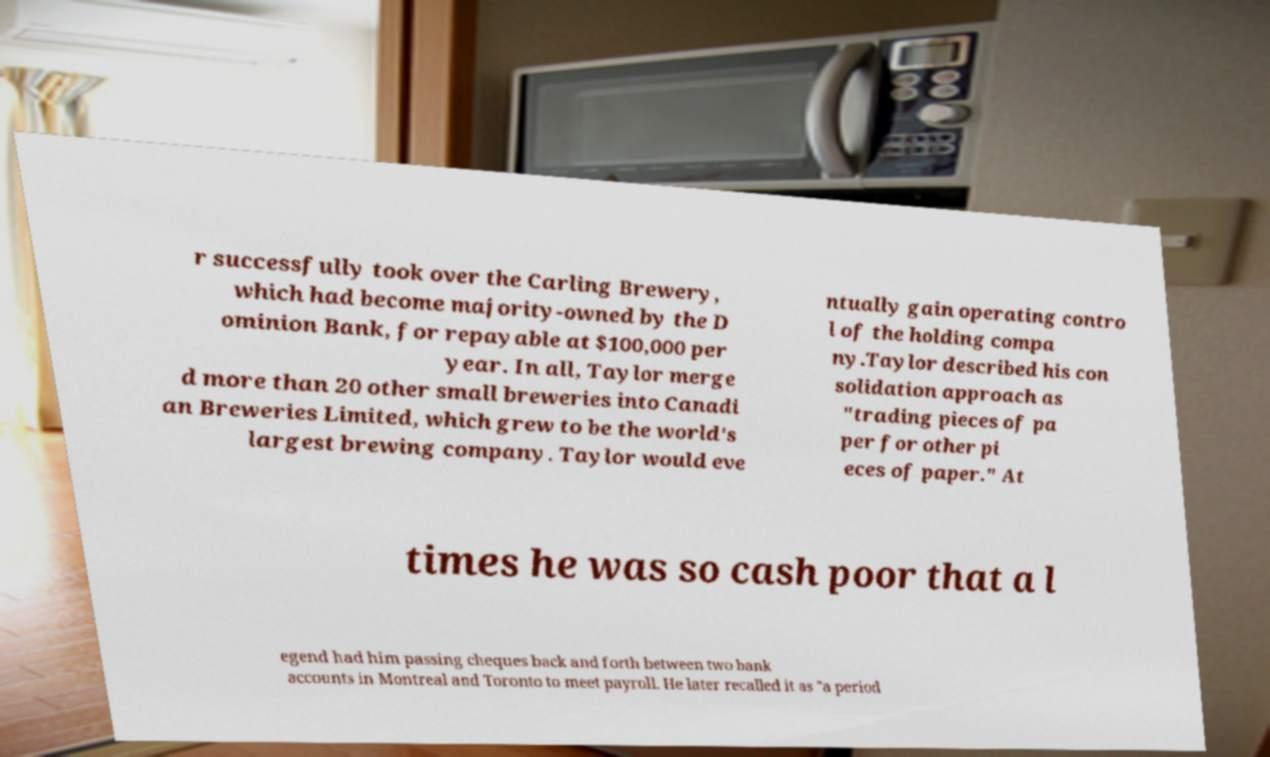Could you assist in decoding the text presented in this image and type it out clearly? r successfully took over the Carling Brewery, which had become majority-owned by the D ominion Bank, for repayable at $100,000 per year. In all, Taylor merge d more than 20 other small breweries into Canadi an Breweries Limited, which grew to be the world's largest brewing company. Taylor would eve ntually gain operating contro l of the holding compa ny.Taylor described his con solidation approach as "trading pieces of pa per for other pi eces of paper." At times he was so cash poor that a l egend had him passing cheques back and forth between two bank accounts in Montreal and Toronto to meet payroll. He later recalled it as "a period 